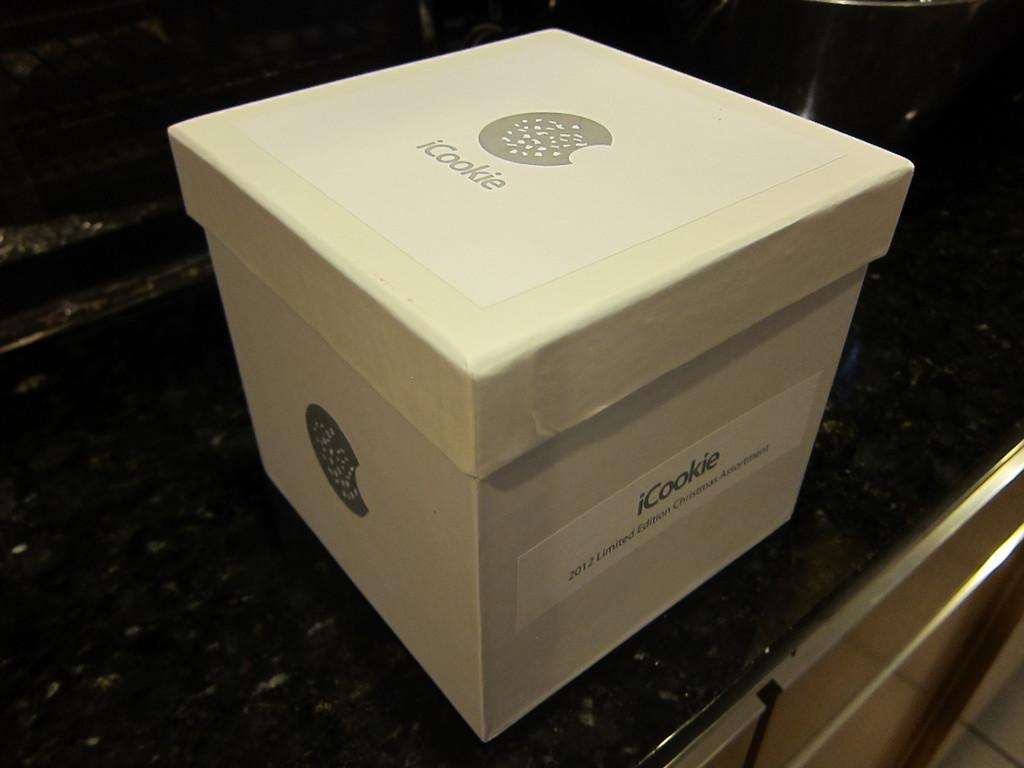<image>
Provide a brief description of the given image. a box that is labeled on the top and the side as 'icookie' 